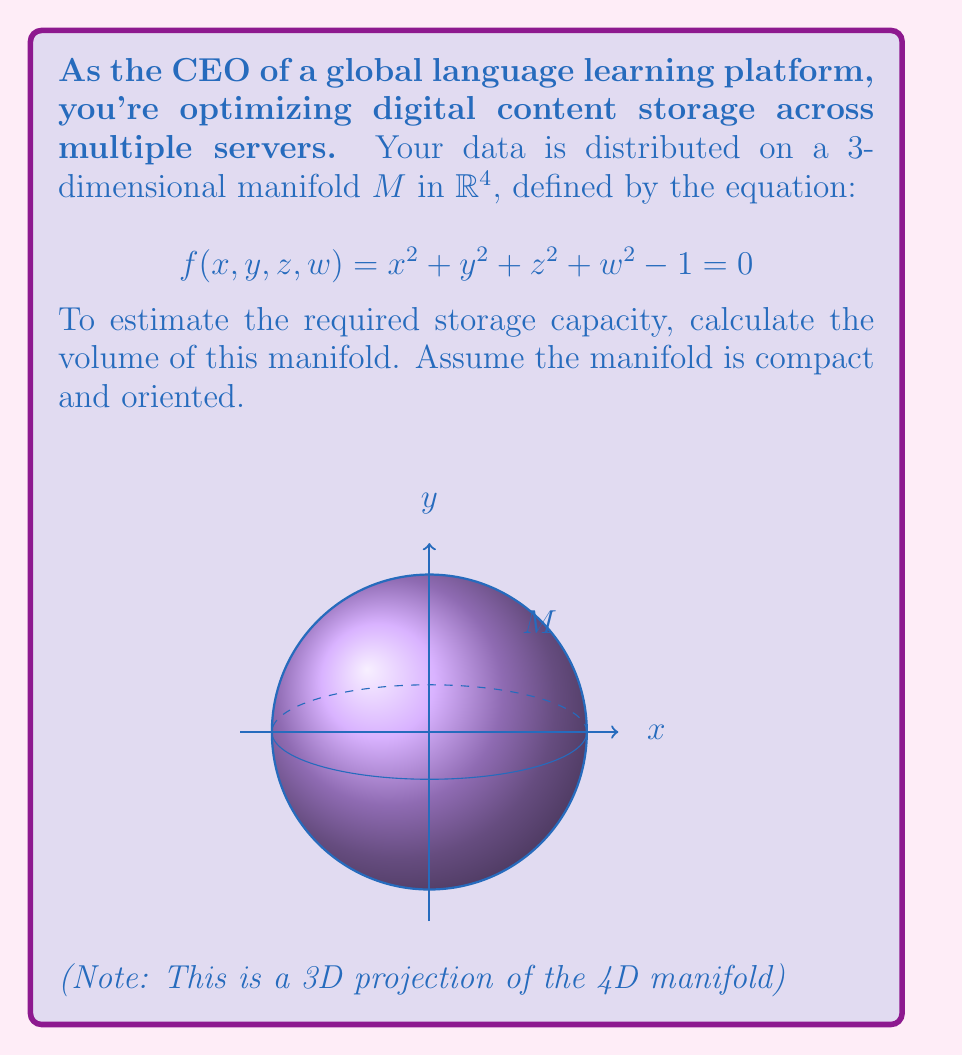Can you solve this math problem? Let's approach this step-by-step:

1) The manifold $M$ is actually a 3-sphere $S^3$ embedded in $\mathbb{R}^4$. This is because the equation $x^2 + y^2 + z^2 + w^2 = 1$ defines a sphere in 4D space.

2) To calculate the volume of this manifold, we can use the formula for the volume of an n-sphere:

   $$V_n = \frac{2\pi^{n/2}}{n\Gamma(n/2)}R^n$$

   where $n$ is the dimension of the sphere, $R$ is the radius, and $\Gamma$ is the gamma function.

3) In our case, $n=3$ (3-dimensional manifold) and $R=1$ (unit sphere). Let's substitute these values:

   $$V_3 = \frac{2\pi^{3/2}}{3\Gamma(3/2)}1^3 = \frac{2\pi^{3/2}}{3\Gamma(3/2)}$$

4) Now, we need to evaluate $\Gamma(3/2)$. Recall that for half-integers:

   $$\Gamma(n+\frac{1}{2}) = \frac{(2n)!}{4^n n!}\sqrt{\pi}$$

   For $n=1$, we get:

   $$\Gamma(\frac{3}{2}) = \frac{2!}{4^1 1!}\sqrt{\pi} = \frac{\sqrt{\pi}}{2}$$

5) Substituting this back into our volume formula:

   $$V_3 = \frac{2\pi^{3/2}}{3(\frac{\sqrt{\pi}}{2})} = \frac{4\pi^{3/2}}{3\sqrt{\pi}} = \frac{4\pi}{3}$$

Thus, the volume of the manifold is $\frac{4\pi}{3}$.
Answer: $\frac{4\pi}{3}$ 